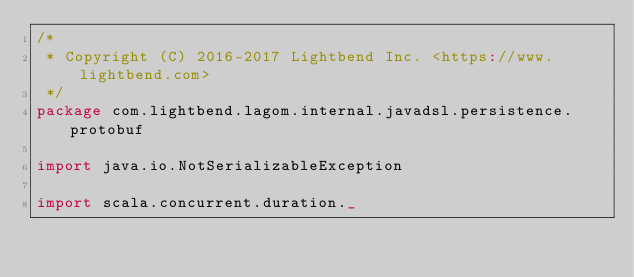Convert code to text. <code><loc_0><loc_0><loc_500><loc_500><_Scala_>/*
 * Copyright (C) 2016-2017 Lightbend Inc. <https://www.lightbend.com>
 */
package com.lightbend.lagom.internal.javadsl.persistence.protobuf

import java.io.NotSerializableException

import scala.concurrent.duration._</code> 